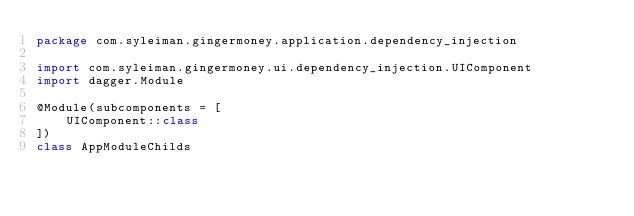Convert code to text. <code><loc_0><loc_0><loc_500><loc_500><_Kotlin_>package com.syleiman.gingermoney.application.dependency_injection

import com.syleiman.gingermoney.ui.dependency_injection.UIComponent
import dagger.Module

@Module(subcomponents = [
    UIComponent::class
])
class AppModuleChilds</code> 